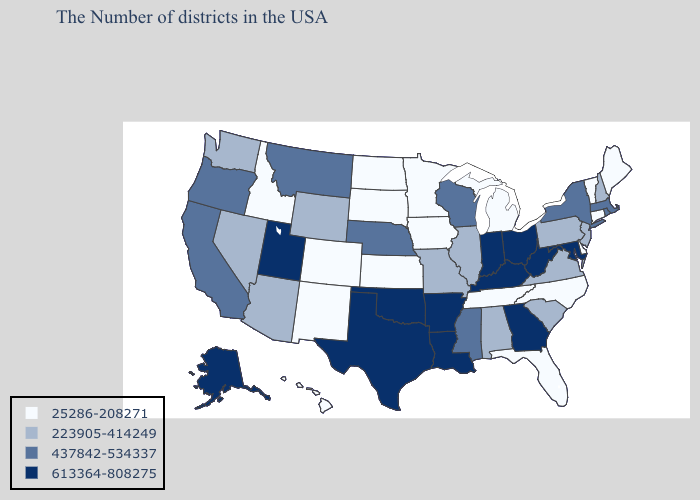Does Wisconsin have a lower value than Texas?
Write a very short answer. Yes. Name the states that have a value in the range 437842-534337?
Keep it brief. Massachusetts, Rhode Island, New York, Wisconsin, Mississippi, Nebraska, Montana, California, Oregon. Among the states that border North Carolina , does Georgia have the lowest value?
Give a very brief answer. No. What is the lowest value in the MidWest?
Write a very short answer. 25286-208271. How many symbols are there in the legend?
Quick response, please. 4. Which states have the lowest value in the Northeast?
Short answer required. Maine, Vermont, Connecticut. Name the states that have a value in the range 25286-208271?
Concise answer only. Maine, Vermont, Connecticut, Delaware, North Carolina, Florida, Michigan, Tennessee, Minnesota, Iowa, Kansas, South Dakota, North Dakota, Colorado, New Mexico, Idaho, Hawaii. Does the map have missing data?
Answer briefly. No. Does the map have missing data?
Short answer required. No. Name the states that have a value in the range 437842-534337?
Short answer required. Massachusetts, Rhode Island, New York, Wisconsin, Mississippi, Nebraska, Montana, California, Oregon. Does the first symbol in the legend represent the smallest category?
Short answer required. Yes. Does New Jersey have the highest value in the USA?
Quick response, please. No. Which states hav the highest value in the Northeast?
Concise answer only. Massachusetts, Rhode Island, New York. What is the value of Connecticut?
Give a very brief answer. 25286-208271. 